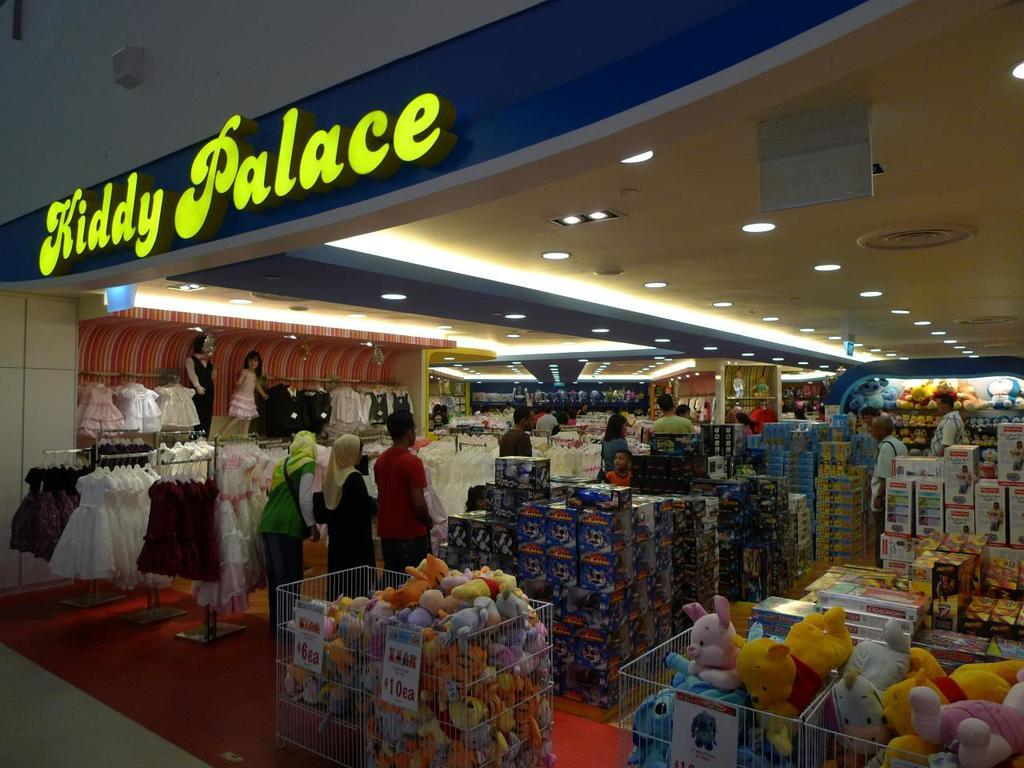<image>
Provide a brief description of the given image. Looking into a clothing store called Kiddy Palace 